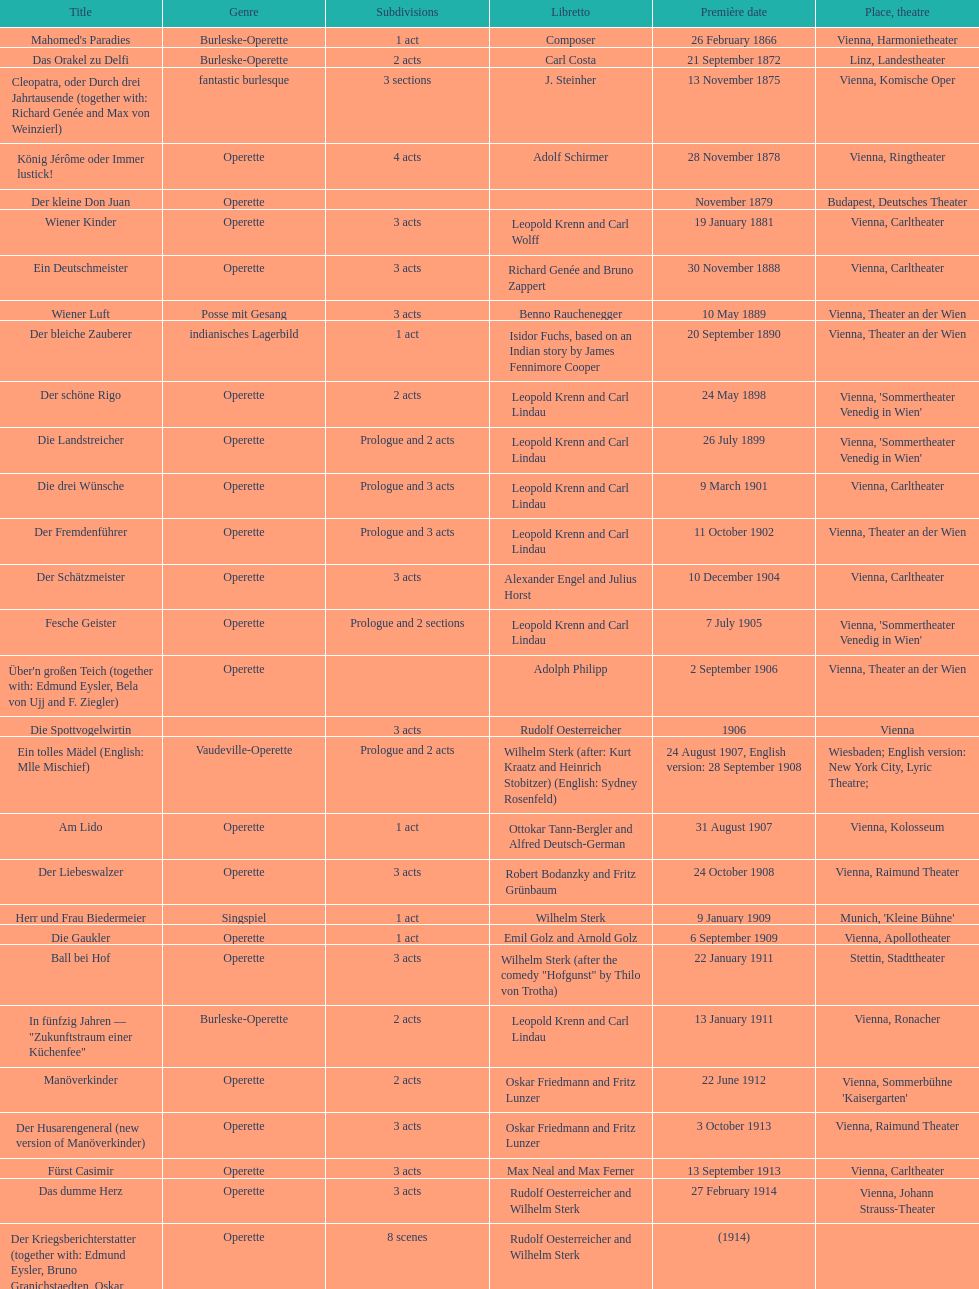In what year was his final operetta released? 1930. 